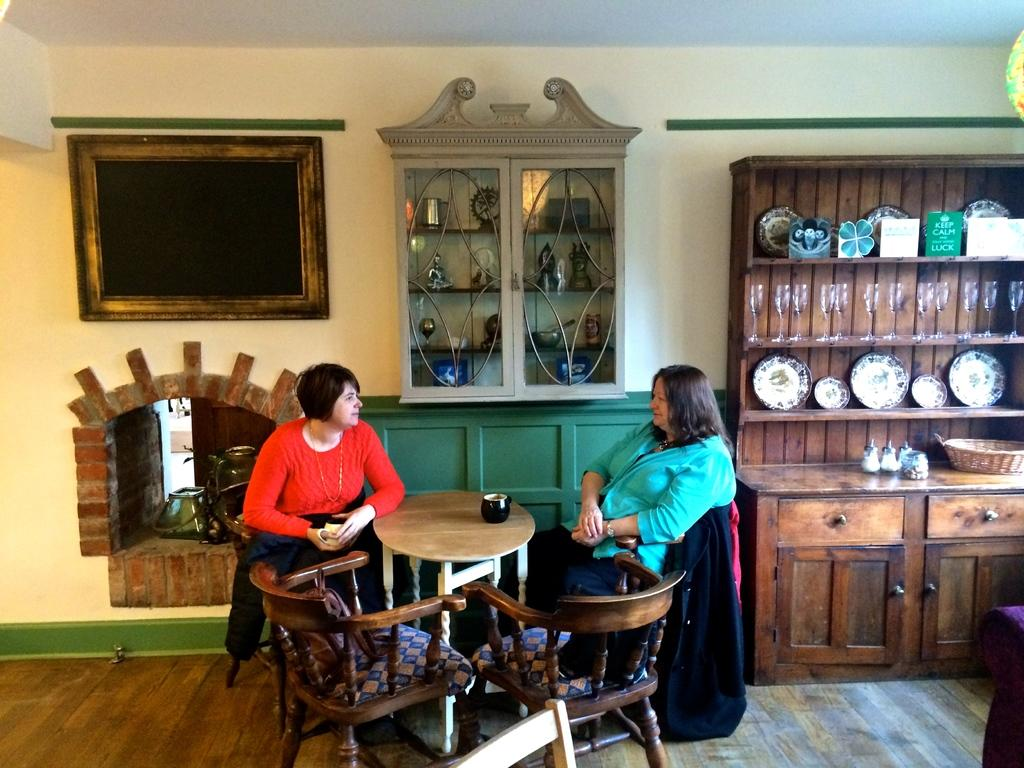How many people are in the image? There are two women in the image. What are the women doing in the image? The women are seated on chairs and speaking to each other. What is present in the image that the women might be using for support or comfort? There is a table in the image that the women might be using. What type of architectural feature is present in the image? There is a fireplace in the image. What other object can be seen in the image? There is a wooden stand in the image. What type of humor can be heard in the song that the women are singing in the image? There is no song or humor present in the image; the women are simply speaking to each other. 